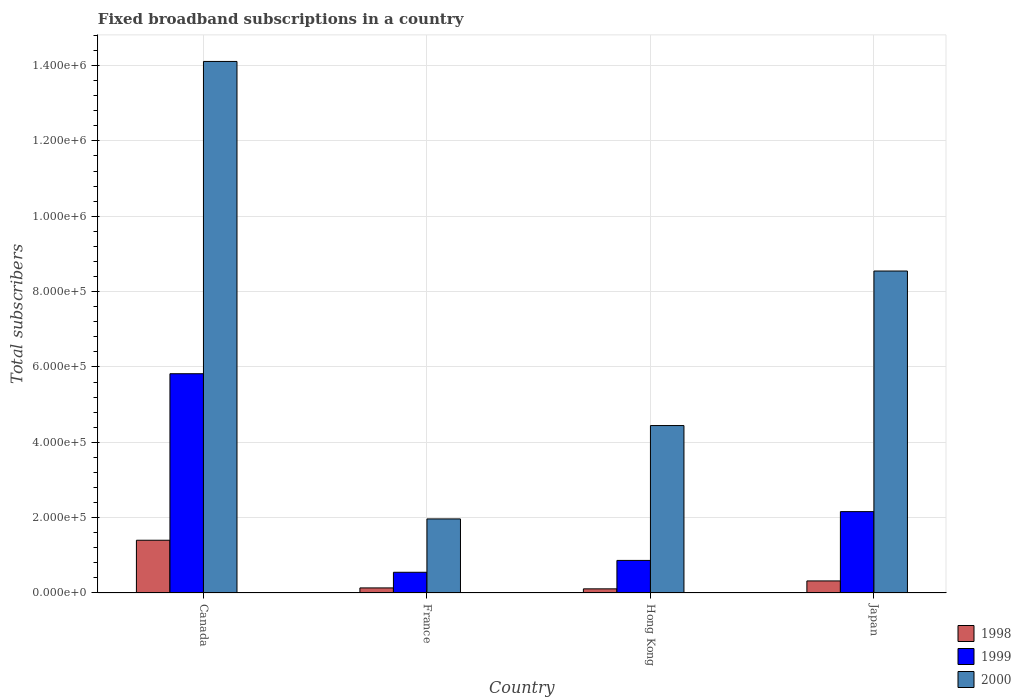How many different coloured bars are there?
Your answer should be very brief. 3. Are the number of bars on each tick of the X-axis equal?
Your response must be concise. Yes. How many bars are there on the 3rd tick from the left?
Make the answer very short. 3. In how many cases, is the number of bars for a given country not equal to the number of legend labels?
Keep it short and to the point. 0. What is the number of broadband subscriptions in 1998 in Hong Kong?
Your answer should be very brief. 1.10e+04. Across all countries, what is the maximum number of broadband subscriptions in 1999?
Ensure brevity in your answer.  5.82e+05. Across all countries, what is the minimum number of broadband subscriptions in 1998?
Give a very brief answer. 1.10e+04. In which country was the number of broadband subscriptions in 1998 minimum?
Offer a very short reply. Hong Kong. What is the total number of broadband subscriptions in 1998 in the graph?
Provide a short and direct response. 1.96e+05. What is the difference between the number of broadband subscriptions in 1998 in Hong Kong and that in Japan?
Offer a very short reply. -2.10e+04. What is the difference between the number of broadband subscriptions in 1998 in Hong Kong and the number of broadband subscriptions in 2000 in France?
Ensure brevity in your answer.  -1.86e+05. What is the average number of broadband subscriptions in 2000 per country?
Make the answer very short. 7.27e+05. What is the difference between the number of broadband subscriptions of/in 2000 and number of broadband subscriptions of/in 1999 in Hong Kong?
Keep it short and to the point. 3.58e+05. In how many countries, is the number of broadband subscriptions in 2000 greater than 360000?
Give a very brief answer. 3. What is the ratio of the number of broadband subscriptions in 1998 in Hong Kong to that in Japan?
Offer a very short reply. 0.34. Is the number of broadband subscriptions in 1998 in Canada less than that in Hong Kong?
Your answer should be compact. No. What is the difference between the highest and the second highest number of broadband subscriptions in 1998?
Your answer should be compact. 1.08e+05. What is the difference between the highest and the lowest number of broadband subscriptions in 1999?
Your answer should be compact. 5.27e+05. In how many countries, is the number of broadband subscriptions in 1998 greater than the average number of broadband subscriptions in 1998 taken over all countries?
Offer a terse response. 1. Is it the case that in every country, the sum of the number of broadband subscriptions in 1998 and number of broadband subscriptions in 2000 is greater than the number of broadband subscriptions in 1999?
Ensure brevity in your answer.  Yes. What is the difference between two consecutive major ticks on the Y-axis?
Provide a succinct answer. 2.00e+05. Does the graph contain grids?
Offer a terse response. Yes. How are the legend labels stacked?
Keep it short and to the point. Vertical. What is the title of the graph?
Offer a terse response. Fixed broadband subscriptions in a country. What is the label or title of the Y-axis?
Your response must be concise. Total subscribers. What is the Total subscribers of 1999 in Canada?
Your answer should be compact. 5.82e+05. What is the Total subscribers in 2000 in Canada?
Keep it short and to the point. 1.41e+06. What is the Total subscribers of 1998 in France?
Offer a terse response. 1.35e+04. What is the Total subscribers in 1999 in France?
Give a very brief answer. 5.50e+04. What is the Total subscribers of 2000 in France?
Make the answer very short. 1.97e+05. What is the Total subscribers in 1998 in Hong Kong?
Provide a short and direct response. 1.10e+04. What is the Total subscribers of 1999 in Hong Kong?
Keep it short and to the point. 8.65e+04. What is the Total subscribers of 2000 in Hong Kong?
Make the answer very short. 4.44e+05. What is the Total subscribers in 1998 in Japan?
Your answer should be very brief. 3.20e+04. What is the Total subscribers of 1999 in Japan?
Offer a very short reply. 2.16e+05. What is the Total subscribers in 2000 in Japan?
Offer a terse response. 8.55e+05. Across all countries, what is the maximum Total subscribers in 1998?
Provide a short and direct response. 1.40e+05. Across all countries, what is the maximum Total subscribers in 1999?
Your answer should be compact. 5.82e+05. Across all countries, what is the maximum Total subscribers in 2000?
Offer a very short reply. 1.41e+06. Across all countries, what is the minimum Total subscribers of 1998?
Give a very brief answer. 1.10e+04. Across all countries, what is the minimum Total subscribers in 1999?
Provide a short and direct response. 5.50e+04. Across all countries, what is the minimum Total subscribers of 2000?
Keep it short and to the point. 1.97e+05. What is the total Total subscribers of 1998 in the graph?
Your answer should be very brief. 1.96e+05. What is the total Total subscribers in 1999 in the graph?
Keep it short and to the point. 9.39e+05. What is the total Total subscribers of 2000 in the graph?
Your answer should be compact. 2.91e+06. What is the difference between the Total subscribers of 1998 in Canada and that in France?
Offer a very short reply. 1.27e+05. What is the difference between the Total subscribers of 1999 in Canada and that in France?
Provide a succinct answer. 5.27e+05. What is the difference between the Total subscribers of 2000 in Canada and that in France?
Provide a short and direct response. 1.21e+06. What is the difference between the Total subscribers of 1998 in Canada and that in Hong Kong?
Give a very brief answer. 1.29e+05. What is the difference between the Total subscribers of 1999 in Canada and that in Hong Kong?
Make the answer very short. 4.96e+05. What is the difference between the Total subscribers of 2000 in Canada and that in Hong Kong?
Give a very brief answer. 9.66e+05. What is the difference between the Total subscribers of 1998 in Canada and that in Japan?
Give a very brief answer. 1.08e+05. What is the difference between the Total subscribers of 1999 in Canada and that in Japan?
Ensure brevity in your answer.  3.66e+05. What is the difference between the Total subscribers in 2000 in Canada and that in Japan?
Provide a succinct answer. 5.56e+05. What is the difference between the Total subscribers in 1998 in France and that in Hong Kong?
Your response must be concise. 2464. What is the difference between the Total subscribers of 1999 in France and that in Hong Kong?
Your answer should be very brief. -3.15e+04. What is the difference between the Total subscribers of 2000 in France and that in Hong Kong?
Your answer should be very brief. -2.48e+05. What is the difference between the Total subscribers of 1998 in France and that in Japan?
Your response must be concise. -1.85e+04. What is the difference between the Total subscribers of 1999 in France and that in Japan?
Provide a short and direct response. -1.61e+05. What is the difference between the Total subscribers in 2000 in France and that in Japan?
Give a very brief answer. -6.58e+05. What is the difference between the Total subscribers in 1998 in Hong Kong and that in Japan?
Make the answer very short. -2.10e+04. What is the difference between the Total subscribers in 1999 in Hong Kong and that in Japan?
Offer a terse response. -1.30e+05. What is the difference between the Total subscribers of 2000 in Hong Kong and that in Japan?
Your answer should be compact. -4.10e+05. What is the difference between the Total subscribers in 1998 in Canada and the Total subscribers in 1999 in France?
Provide a short and direct response. 8.50e+04. What is the difference between the Total subscribers in 1998 in Canada and the Total subscribers in 2000 in France?
Offer a very short reply. -5.66e+04. What is the difference between the Total subscribers in 1999 in Canada and the Total subscribers in 2000 in France?
Ensure brevity in your answer.  3.85e+05. What is the difference between the Total subscribers in 1998 in Canada and the Total subscribers in 1999 in Hong Kong?
Provide a short and direct response. 5.35e+04. What is the difference between the Total subscribers of 1998 in Canada and the Total subscribers of 2000 in Hong Kong?
Your answer should be very brief. -3.04e+05. What is the difference between the Total subscribers of 1999 in Canada and the Total subscribers of 2000 in Hong Kong?
Give a very brief answer. 1.38e+05. What is the difference between the Total subscribers in 1998 in Canada and the Total subscribers in 1999 in Japan?
Give a very brief answer. -7.60e+04. What is the difference between the Total subscribers of 1998 in Canada and the Total subscribers of 2000 in Japan?
Offer a terse response. -7.15e+05. What is the difference between the Total subscribers of 1999 in Canada and the Total subscribers of 2000 in Japan?
Give a very brief answer. -2.73e+05. What is the difference between the Total subscribers in 1998 in France and the Total subscribers in 1999 in Hong Kong?
Provide a succinct answer. -7.30e+04. What is the difference between the Total subscribers of 1998 in France and the Total subscribers of 2000 in Hong Kong?
Your answer should be compact. -4.31e+05. What is the difference between the Total subscribers in 1999 in France and the Total subscribers in 2000 in Hong Kong?
Offer a very short reply. -3.89e+05. What is the difference between the Total subscribers of 1998 in France and the Total subscribers of 1999 in Japan?
Make the answer very short. -2.03e+05. What is the difference between the Total subscribers in 1998 in France and the Total subscribers in 2000 in Japan?
Give a very brief answer. -8.41e+05. What is the difference between the Total subscribers of 1999 in France and the Total subscribers of 2000 in Japan?
Offer a very short reply. -8.00e+05. What is the difference between the Total subscribers of 1998 in Hong Kong and the Total subscribers of 1999 in Japan?
Keep it short and to the point. -2.05e+05. What is the difference between the Total subscribers of 1998 in Hong Kong and the Total subscribers of 2000 in Japan?
Give a very brief answer. -8.44e+05. What is the difference between the Total subscribers of 1999 in Hong Kong and the Total subscribers of 2000 in Japan?
Give a very brief answer. -7.68e+05. What is the average Total subscribers of 1998 per country?
Your answer should be very brief. 4.91e+04. What is the average Total subscribers in 1999 per country?
Offer a very short reply. 2.35e+05. What is the average Total subscribers of 2000 per country?
Provide a short and direct response. 7.27e+05. What is the difference between the Total subscribers of 1998 and Total subscribers of 1999 in Canada?
Give a very brief answer. -4.42e+05. What is the difference between the Total subscribers in 1998 and Total subscribers in 2000 in Canada?
Your response must be concise. -1.27e+06. What is the difference between the Total subscribers in 1999 and Total subscribers in 2000 in Canada?
Ensure brevity in your answer.  -8.29e+05. What is the difference between the Total subscribers in 1998 and Total subscribers in 1999 in France?
Offer a terse response. -4.15e+04. What is the difference between the Total subscribers of 1998 and Total subscribers of 2000 in France?
Make the answer very short. -1.83e+05. What is the difference between the Total subscribers of 1999 and Total subscribers of 2000 in France?
Give a very brief answer. -1.42e+05. What is the difference between the Total subscribers in 1998 and Total subscribers in 1999 in Hong Kong?
Your answer should be compact. -7.55e+04. What is the difference between the Total subscribers of 1998 and Total subscribers of 2000 in Hong Kong?
Ensure brevity in your answer.  -4.33e+05. What is the difference between the Total subscribers of 1999 and Total subscribers of 2000 in Hong Kong?
Keep it short and to the point. -3.58e+05. What is the difference between the Total subscribers in 1998 and Total subscribers in 1999 in Japan?
Ensure brevity in your answer.  -1.84e+05. What is the difference between the Total subscribers in 1998 and Total subscribers in 2000 in Japan?
Keep it short and to the point. -8.23e+05. What is the difference between the Total subscribers of 1999 and Total subscribers of 2000 in Japan?
Make the answer very short. -6.39e+05. What is the ratio of the Total subscribers of 1998 in Canada to that in France?
Your response must be concise. 10.4. What is the ratio of the Total subscribers of 1999 in Canada to that in France?
Your response must be concise. 10.58. What is the ratio of the Total subscribers of 2000 in Canada to that in France?
Provide a short and direct response. 7.18. What is the ratio of the Total subscribers of 1998 in Canada to that in Hong Kong?
Your answer should be compact. 12.73. What is the ratio of the Total subscribers in 1999 in Canada to that in Hong Kong?
Offer a very short reply. 6.73. What is the ratio of the Total subscribers in 2000 in Canada to that in Hong Kong?
Provide a succinct answer. 3.17. What is the ratio of the Total subscribers in 1998 in Canada to that in Japan?
Ensure brevity in your answer.  4.38. What is the ratio of the Total subscribers in 1999 in Canada to that in Japan?
Your answer should be compact. 2.69. What is the ratio of the Total subscribers of 2000 in Canada to that in Japan?
Your answer should be very brief. 1.65. What is the ratio of the Total subscribers of 1998 in France to that in Hong Kong?
Your response must be concise. 1.22. What is the ratio of the Total subscribers of 1999 in France to that in Hong Kong?
Provide a succinct answer. 0.64. What is the ratio of the Total subscribers in 2000 in France to that in Hong Kong?
Your response must be concise. 0.44. What is the ratio of the Total subscribers in 1998 in France to that in Japan?
Give a very brief answer. 0.42. What is the ratio of the Total subscribers in 1999 in France to that in Japan?
Give a very brief answer. 0.25. What is the ratio of the Total subscribers in 2000 in France to that in Japan?
Provide a succinct answer. 0.23. What is the ratio of the Total subscribers of 1998 in Hong Kong to that in Japan?
Your response must be concise. 0.34. What is the ratio of the Total subscribers in 1999 in Hong Kong to that in Japan?
Offer a terse response. 0.4. What is the ratio of the Total subscribers of 2000 in Hong Kong to that in Japan?
Your response must be concise. 0.52. What is the difference between the highest and the second highest Total subscribers of 1998?
Provide a succinct answer. 1.08e+05. What is the difference between the highest and the second highest Total subscribers of 1999?
Give a very brief answer. 3.66e+05. What is the difference between the highest and the second highest Total subscribers in 2000?
Make the answer very short. 5.56e+05. What is the difference between the highest and the lowest Total subscribers of 1998?
Provide a short and direct response. 1.29e+05. What is the difference between the highest and the lowest Total subscribers in 1999?
Ensure brevity in your answer.  5.27e+05. What is the difference between the highest and the lowest Total subscribers of 2000?
Keep it short and to the point. 1.21e+06. 